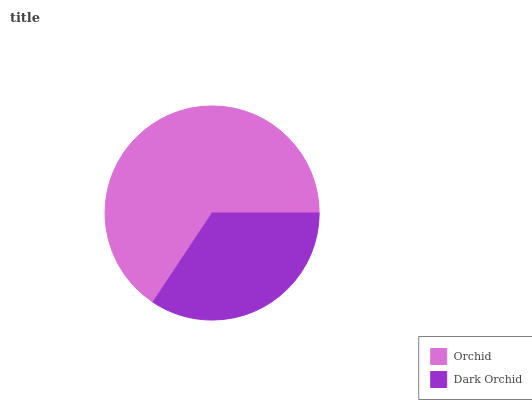Is Dark Orchid the minimum?
Answer yes or no. Yes. Is Orchid the maximum?
Answer yes or no. Yes. Is Dark Orchid the maximum?
Answer yes or no. No. Is Orchid greater than Dark Orchid?
Answer yes or no. Yes. Is Dark Orchid less than Orchid?
Answer yes or no. Yes. Is Dark Orchid greater than Orchid?
Answer yes or no. No. Is Orchid less than Dark Orchid?
Answer yes or no. No. Is Orchid the high median?
Answer yes or no. Yes. Is Dark Orchid the low median?
Answer yes or no. Yes. Is Dark Orchid the high median?
Answer yes or no. No. Is Orchid the low median?
Answer yes or no. No. 